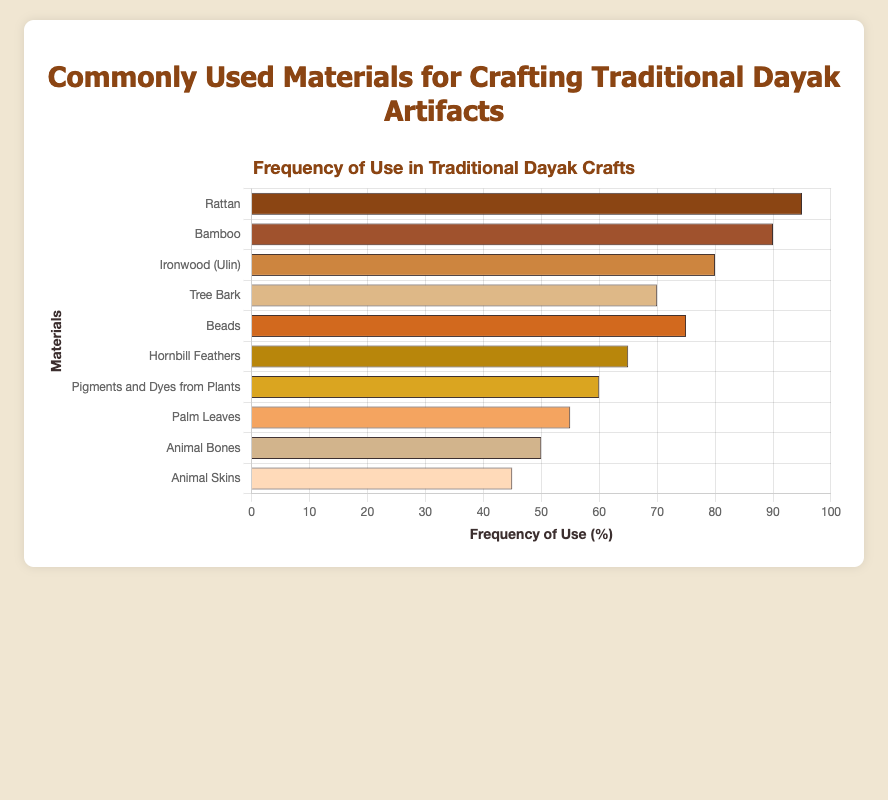Which material is used most frequently in traditional Dayak artifacts? The bar chart shows that the bar for "Rattan" is the longest, indicating the highest frequency of use.
Answer: Rattan Which material is used less frequently, Palm Leaves or Tree Bark? The bar for Palm Leaves is shorter than the bar for Tree Bark, indicating a lower frequency of use.
Answer: Palm Leaves What is the difference in the frequency of use between Rattan and Bamboo? The figure shows the frequency of use for Rattan and Bamboo as 95% and 90% respectively. Subtract 90 from 95: 95 - 90 = 5.
Answer: 5% What is the total frequency of use for Ironwood (Ulin), Beads, and Hornbill Feathers combined? The frequencies are Ironwood (Ulin) = 80%, Beads = 75%, and Hornbill Feathers = 65%. Add these values: 80 + 75 + 65 = 220.
Answer: 220% Which material has the second lowest frequency of use, after Animal Skins? Based on the chart, the bar for Animal Skins is the shortest at 45%, followed by Animal Bones at 50%.
Answer: Animal Bones Are beads used more frequently than pigments and dyes from plants? The figure shows the bar for Beads is at 75%, and the bar for Pigments and Dyes from Plants is at 60%, indicating Beads are used more frequently.
Answer: Yes What is the average frequency of use for the top three most commonly used materials? Rattan = 95%, Bamboo = 90%, and Ironwood (Ulin) = 80%. Add these values and divide by 3: (95 + 90 + 80) / 3 = 88.33%.
Answer: 88.33% How much more frequently are Hornbill Feathers used compared to Animal Skins? The frequencies are Hornbill Feathers = 65% and Animal Skins = 45%. Subtract 45 from 65: 65 - 45 = 20.
Answer: 20% Which material corresponding to the color 'golden brown' has the fifth highest frequency of use? 'Golden brown' represents Beads, and the bar chart shows Beads are the fifth most used material with a frequency of 75%.
Answer: Beads What is the median value of the frequency of use across all materials? Ordering the frequencies: 95, 90, 80, 75, 70, 65, 60, 55, 50, 45. The median is the average of the 5th and 6th values: (70 + 65) / 2 = 67.5.
Answer: 67.5% 